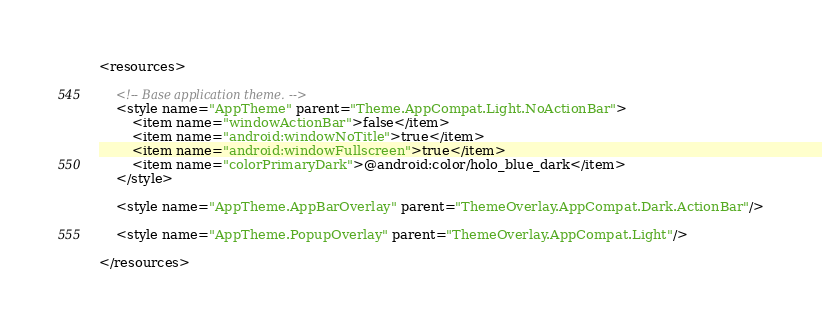<code> <loc_0><loc_0><loc_500><loc_500><_XML_><resources>

    <!-- Base application theme. -->
    <style name="AppTheme" parent="Theme.AppCompat.Light.NoActionBar">
        <item name="windowActionBar">false</item>
        <item name="android:windowNoTitle">true</item>
        <item name="android:windowFullscreen">true</item>
        <item name="colorPrimaryDark">@android:color/holo_blue_dark</item>
    </style>

    <style name="AppTheme.AppBarOverlay" parent="ThemeOverlay.AppCompat.Dark.ActionBar"/>

    <style name="AppTheme.PopupOverlay" parent="ThemeOverlay.AppCompat.Light"/>

</resources>
</code> 